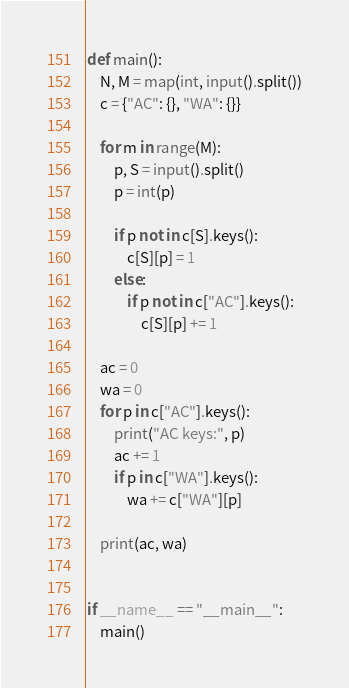Convert code to text. <code><loc_0><loc_0><loc_500><loc_500><_Python_>def main():
    N, M = map(int, input().split())
    c = {"AC": {}, "WA": {}}
    
    for m in range(M):
        p, S = input().split()
        p = int(p)
        
        if p not in c[S].keys():
            c[S][p] = 1
        else:
            if p not in c["AC"].keys():
                c[S][p] += 1

    ac = 0
    wa = 0
    for p in c["AC"].keys():
        print("AC keys:", p)
        ac += 1
        if p in c["WA"].keys():
            wa += c["WA"][p]
    
    print(ac, wa)
        
    
if __name__ == "__main__":
    main()
</code> 